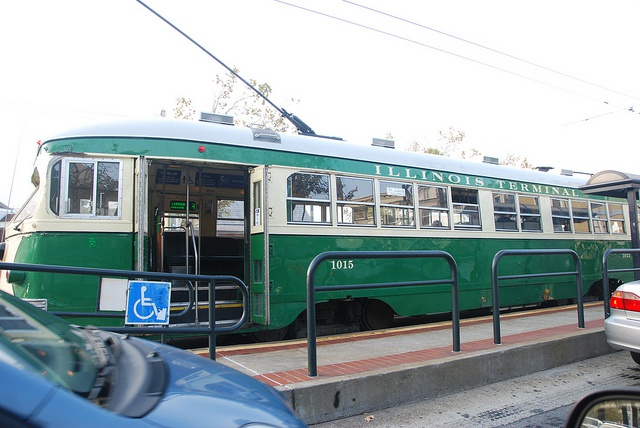Describe the objects in this image and their specific colors. I can see bus in white, lightgray, teal, black, and gray tones, train in white, lightgray, teal, black, and darkgray tones, car in white, gray, and blue tones, and car in white, darkgray, lightgray, gray, and red tones in this image. 